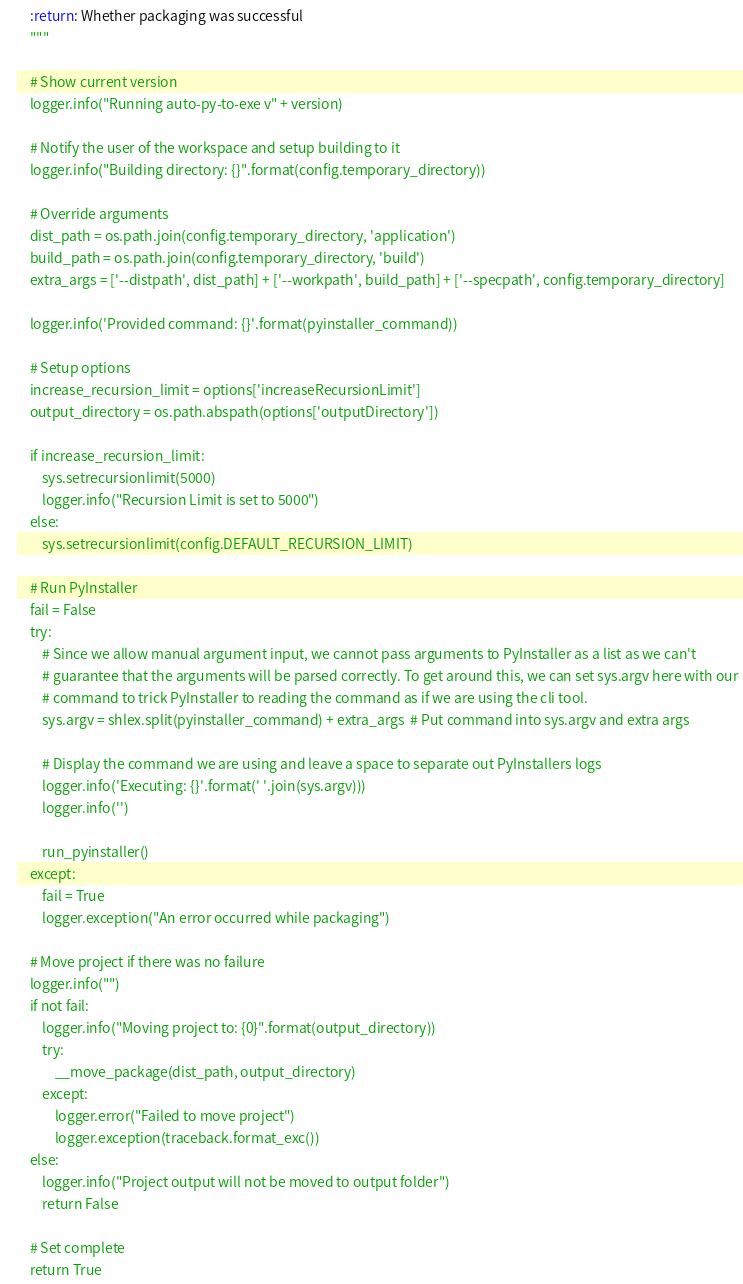<code> <loc_0><loc_0><loc_500><loc_500><_Python_>    :return: Whether packaging was successful
    """

    # Show current version
    logger.info("Running auto-py-to-exe v" + version)

    # Notify the user of the workspace and setup building to it
    logger.info("Building directory: {}".format(config.temporary_directory))

    # Override arguments
    dist_path = os.path.join(config.temporary_directory, 'application')
    build_path = os.path.join(config.temporary_directory, 'build')
    extra_args = ['--distpath', dist_path] + ['--workpath', build_path] + ['--specpath', config.temporary_directory]

    logger.info('Provided command: {}'.format(pyinstaller_command))

    # Setup options
    increase_recursion_limit = options['increaseRecursionLimit']
    output_directory = os.path.abspath(options['outputDirectory'])

    if increase_recursion_limit:
        sys.setrecursionlimit(5000)
        logger.info("Recursion Limit is set to 5000")
    else:
        sys.setrecursionlimit(config.DEFAULT_RECURSION_LIMIT)

    # Run PyInstaller
    fail = False
    try:
        # Since we allow manual argument input, we cannot pass arguments to PyInstaller as a list as we can't
        # guarantee that the arguments will be parsed correctly. To get around this, we can set sys.argv here with our
        # command to trick PyInstaller to reading the command as if we are using the cli tool.
        sys.argv = shlex.split(pyinstaller_command) + extra_args  # Put command into sys.argv and extra args

        # Display the command we are using and leave a space to separate out PyInstallers logs
        logger.info('Executing: {}'.format(' '.join(sys.argv)))
        logger.info('')

        run_pyinstaller()
    except:
        fail = True
        logger.exception("An error occurred while packaging")

    # Move project if there was no failure
    logger.info("")
    if not fail:
        logger.info("Moving project to: {0}".format(output_directory))
        try:
            __move_package(dist_path, output_directory)
        except:
            logger.error("Failed to move project")
            logger.exception(traceback.format_exc())
    else:
        logger.info("Project output will not be moved to output folder")
        return False

    # Set complete
    return True
</code> 